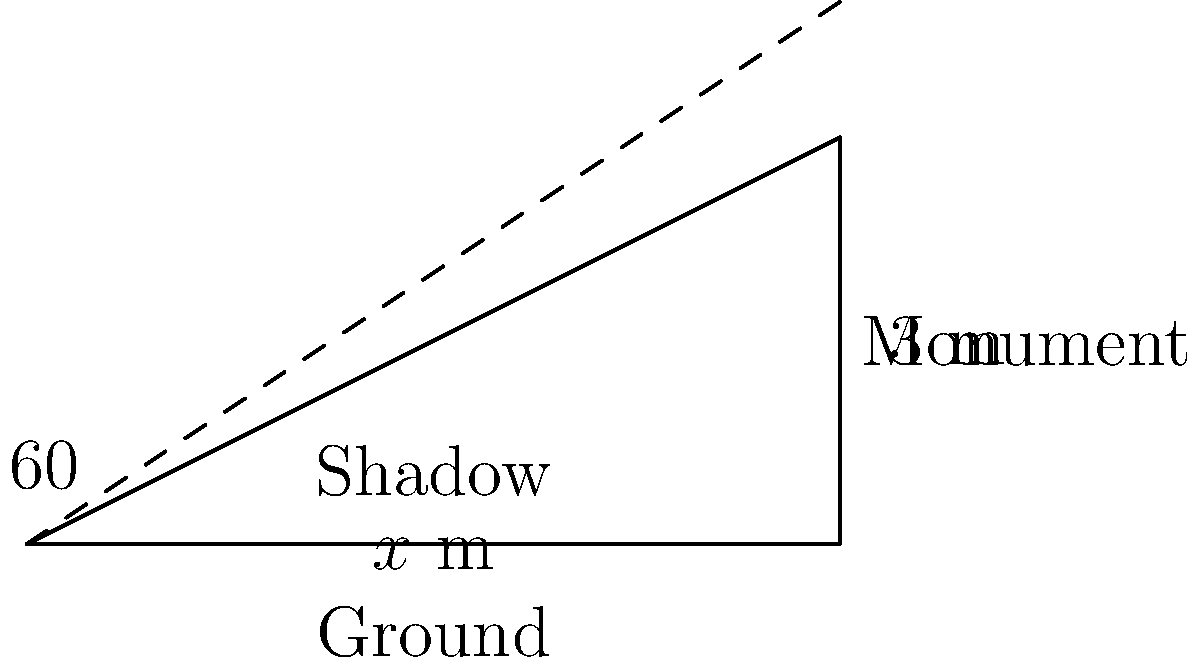In front of the Parliament building in Port Louis, Mauritius, there's a monument dedicated to Sir Seewoosagur Ramgoolam, the first Prime Minister of Mauritius. If the monument is 3 meters tall and casts a shadow at 4:00 PM when the angle of the sun is 60° above the horizon, what is the length of the shadow to the nearest tenth of a meter? Let's approach this step-by-step using trigonometry:

1) We have a right triangle formed by the monument, its shadow, and the ray of sunlight.

2) The monument's height is the opposite side (3 m), and the shadow's length is the adjacent side (let's call it $x$).

3) The angle between the ground and the sun's rays is 60°.

4) We need to use the tangent function, as we're relating the opposite side to the adjacent side:

   $\tan(\theta) = \frac{\text{opposite}}{\text{adjacent}}$

5) Plugging in our values:

   $\tan(60°) = \frac{3}{x}$

6) We know that $\tan(60°) = \sqrt{3}$, so:

   $\sqrt{3} = \frac{3}{x}$

7) Solving for $x$:

   $x = \frac{3}{\sqrt{3}} = \frac{3}{\sqrt{3}} \cdot \frac{\sqrt{3}}{\sqrt{3}} = \frac{3\sqrt{3}}{3} = \sqrt{3}$

8) $\sqrt{3} \approx 1.732$ meters

9) Rounding to the nearest tenth: 1.7 meters
Answer: 1.7 m 